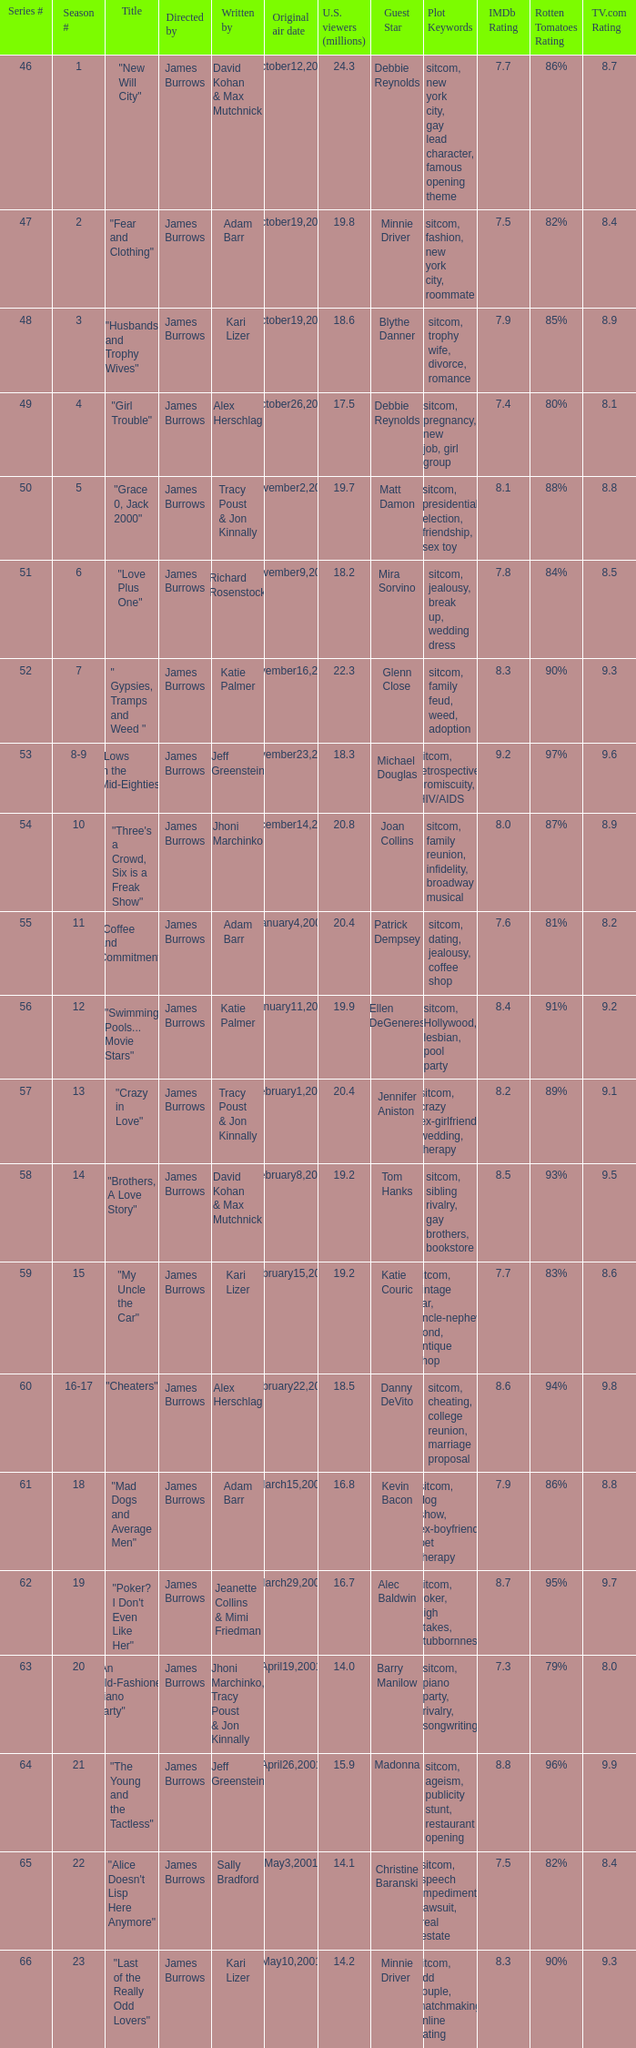Who wrote episode 23 in the season? Kari Lizer. 